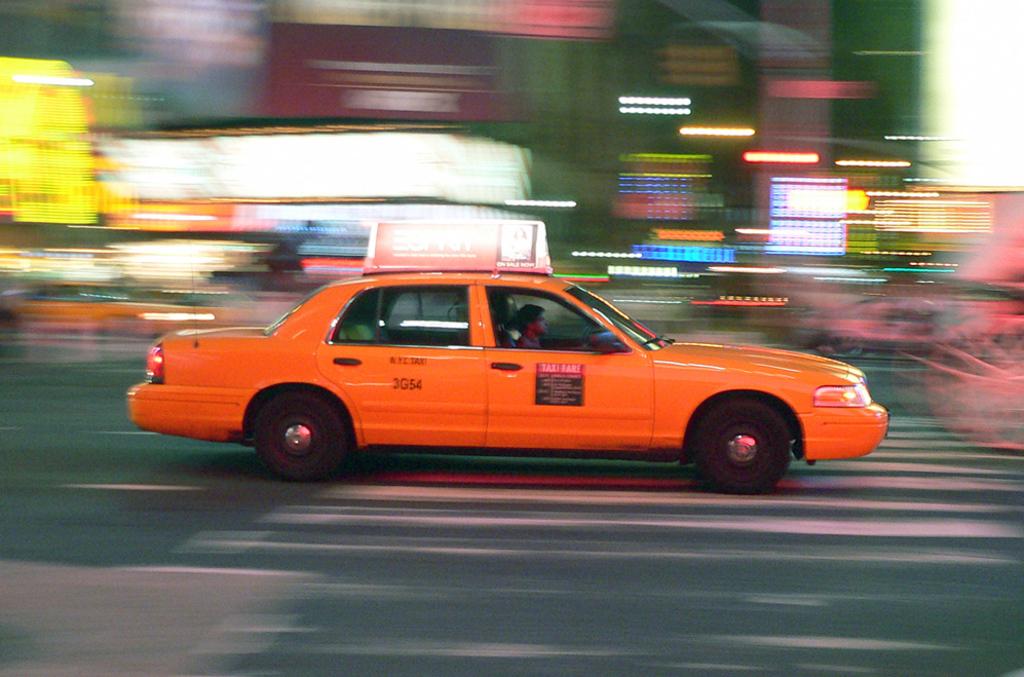What number is the cab?
Provide a short and direct response. 3g54. 